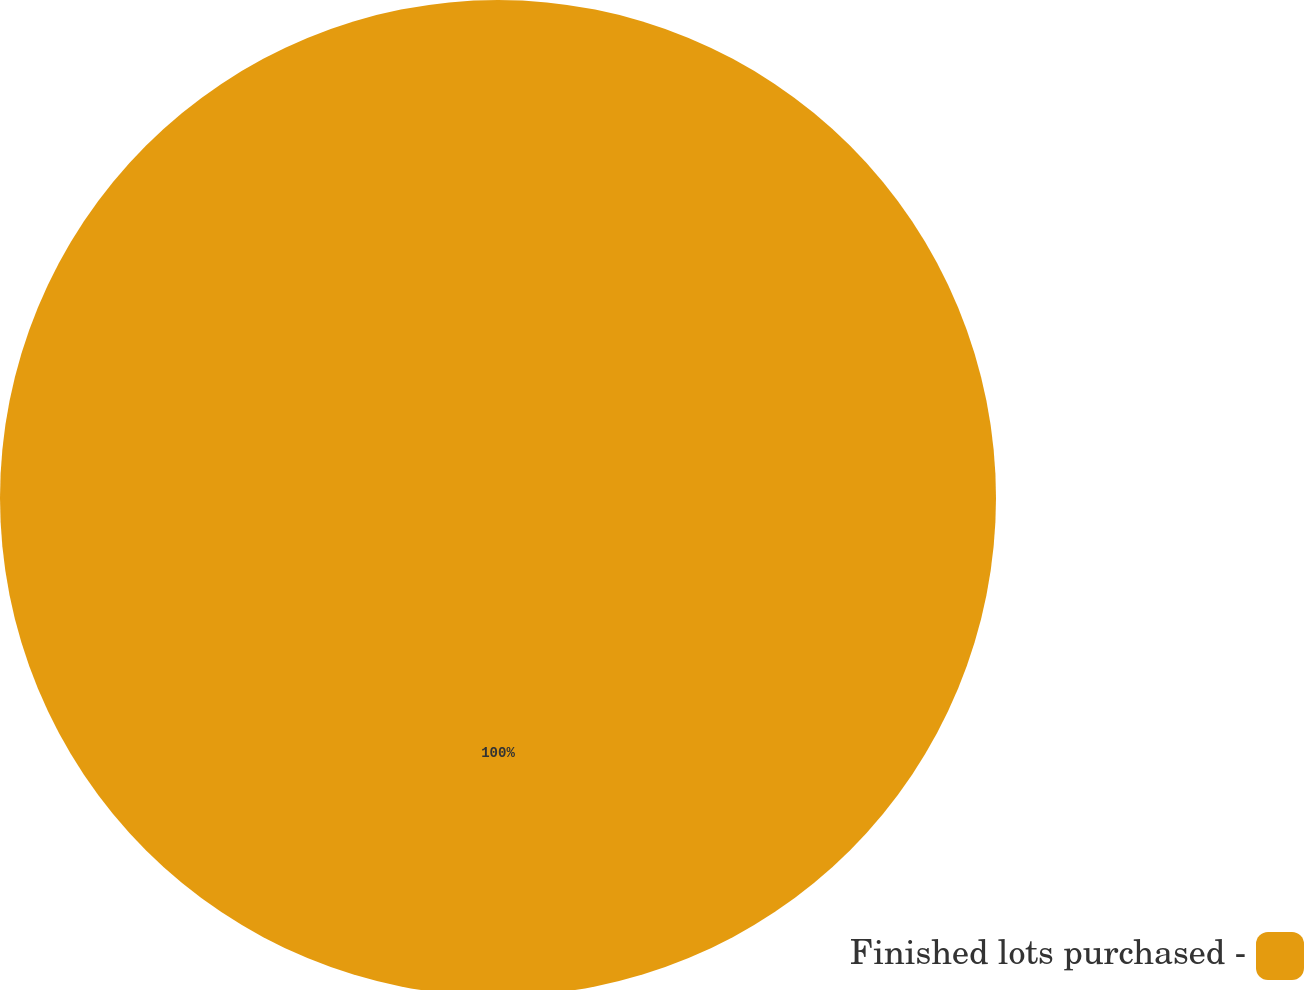Convert chart to OTSL. <chart><loc_0><loc_0><loc_500><loc_500><pie_chart><fcel>Finished lots purchased -<nl><fcel>100.0%<nl></chart> 